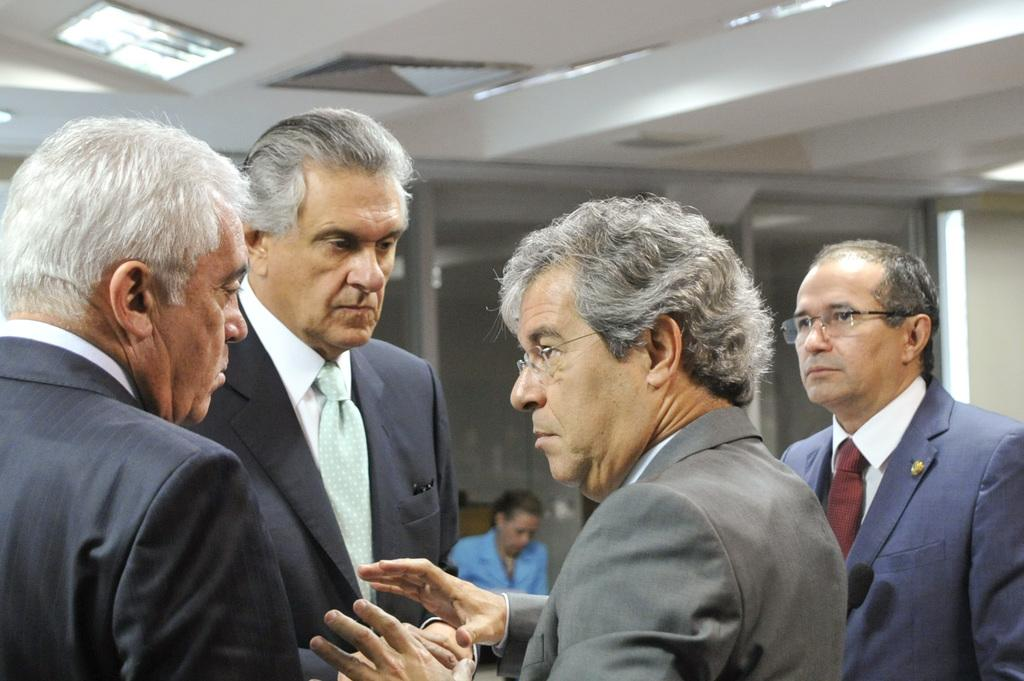How many people are present in the image? There are four men standing and one woman sitting, making a total of five people in the image. What are the men in the image doing? The men are standing in the image. What is the woman in the image doing? The woman is sitting in the image. What can be seen attached to the roof in the image? There is a ceiling light attached to the roof in the image. What type of door can be seen in the background of the image? There appears to be a glass door in the background of the image. How many babies are being covered by the men in the image? There are no babies present in the image, and the men are not covering any babies. 